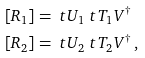<formula> <loc_0><loc_0><loc_500><loc_500>[ R _ { 1 } ] & = \ t U _ { 1 } \ t T _ { 1 } V ^ { \dagger } \\ [ R _ { 2 } ] & = \ t U _ { 2 } \ t T _ { 2 } V ^ { \dagger } \, ,</formula> 